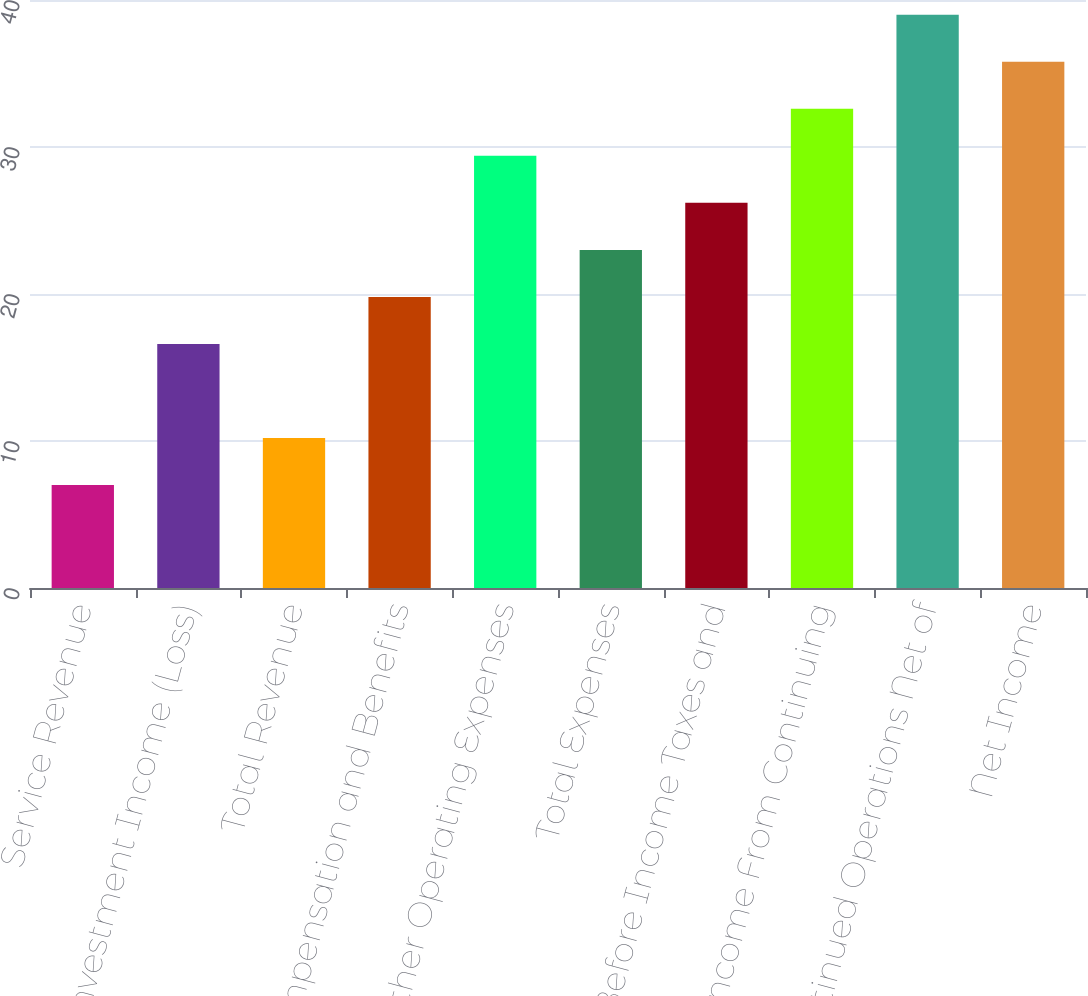Convert chart to OTSL. <chart><loc_0><loc_0><loc_500><loc_500><bar_chart><fcel>Service Revenue<fcel>Investment Income (Loss)<fcel>Total Revenue<fcel>Compensation and Benefits<fcel>Other Operating Expenses<fcel>Total Expenses<fcel>Income Before Income Taxes and<fcel>Income From Continuing<fcel>Discontinued Operations Net of<fcel>Net Income<nl><fcel>7<fcel>16.6<fcel>10.2<fcel>19.8<fcel>29.4<fcel>23<fcel>26.2<fcel>32.6<fcel>39<fcel>35.8<nl></chart> 